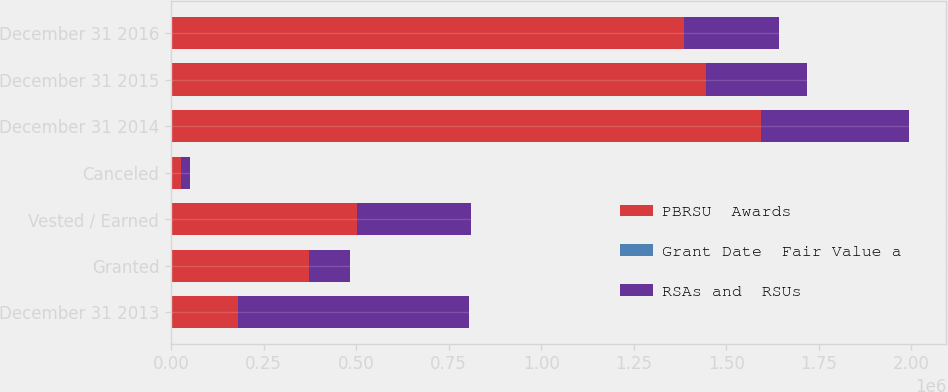Convert chart. <chart><loc_0><loc_0><loc_500><loc_500><stacked_bar_chart><ecel><fcel>December 31 2013<fcel>Granted<fcel>Vested / Earned<fcel>Canceled<fcel>December 31 2014<fcel>December 31 2015<fcel>December 31 2016<nl><fcel>PBRSU  Awards<fcel>182026<fcel>373337<fcel>503324<fcel>27048<fcel>1.59323e+06<fcel>1.44419e+06<fcel>1.38669e+06<nl><fcel>Grant Date  Fair Value a<fcel>64.49<fcel>103.1<fcel>47.98<fcel>74.09<fcel>78.59<fcel>95.59<fcel>107.7<nl><fcel>RSAs and  RSUs<fcel>622021<fcel>109665<fcel>306830<fcel>23785<fcel>401071<fcel>273235<fcel>254387<nl></chart> 